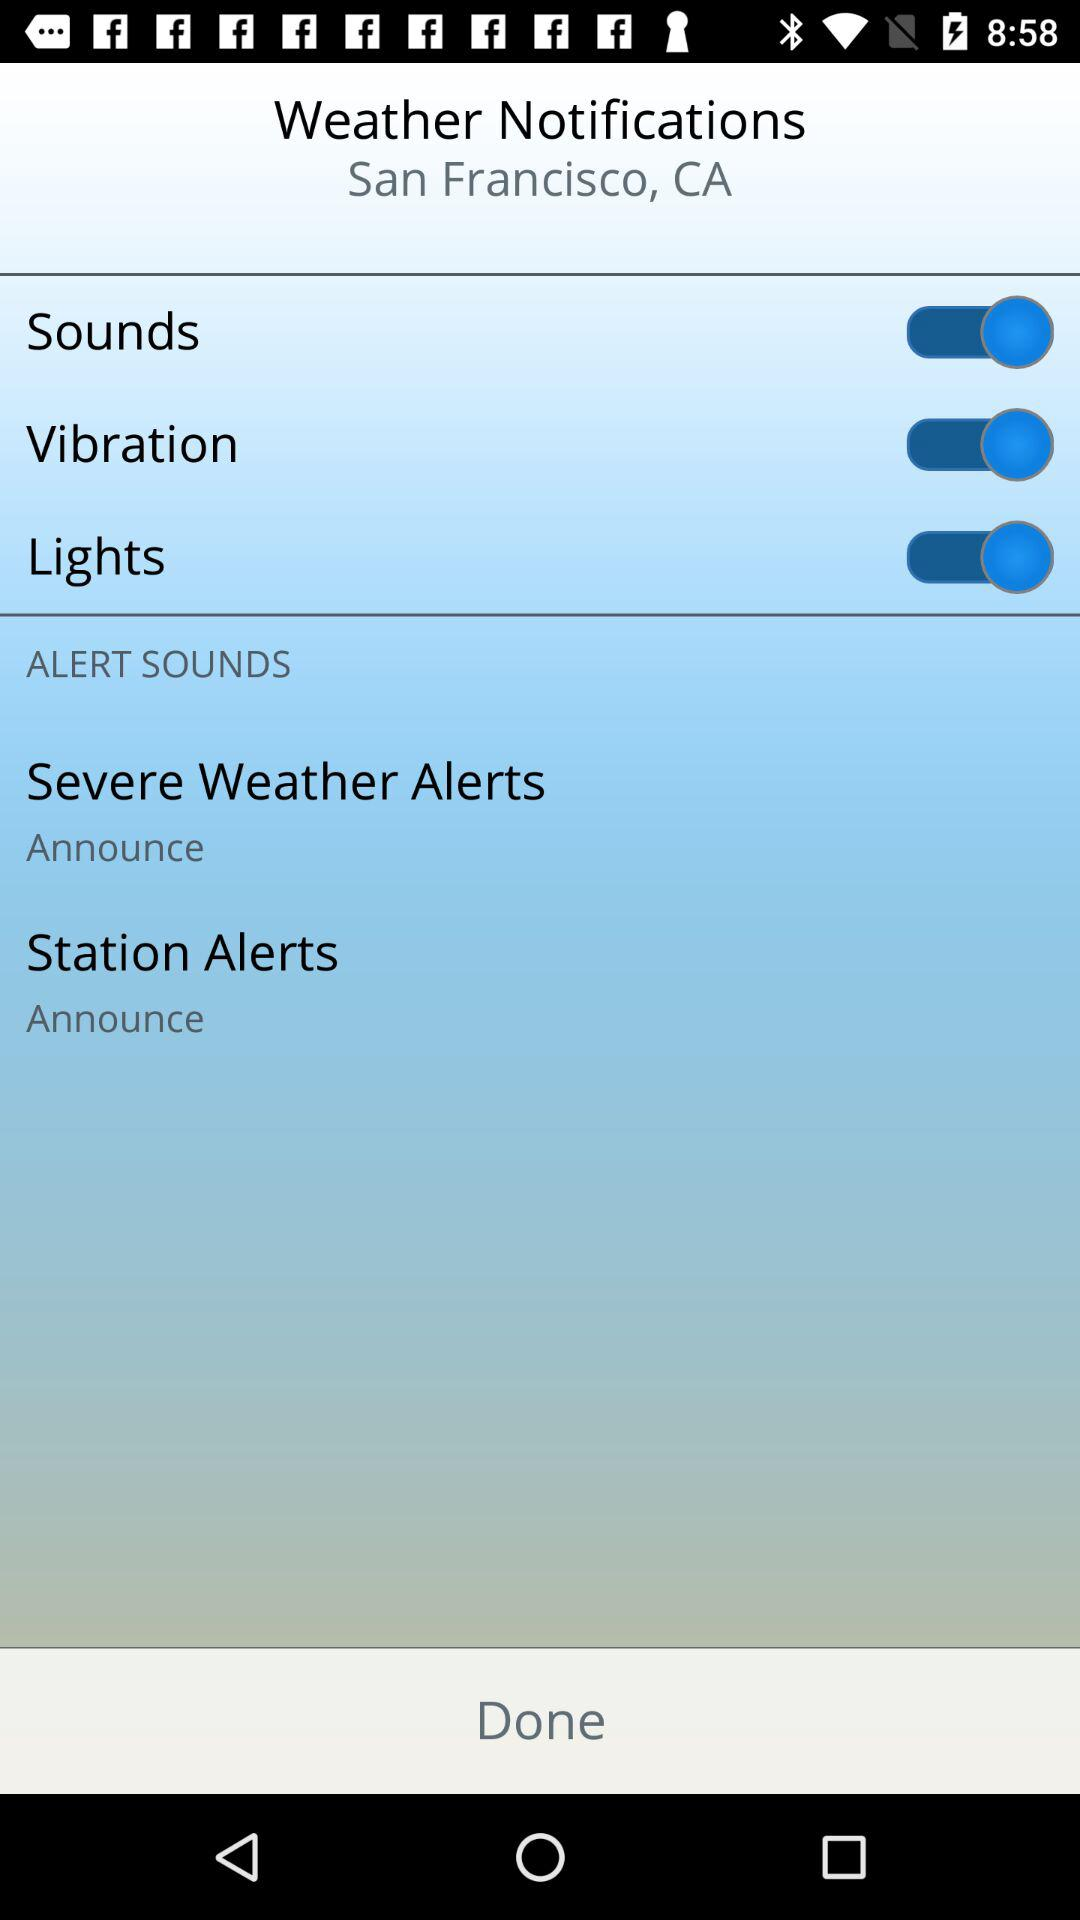How many alert sounds are there?
Answer the question using a single word or phrase. 2 